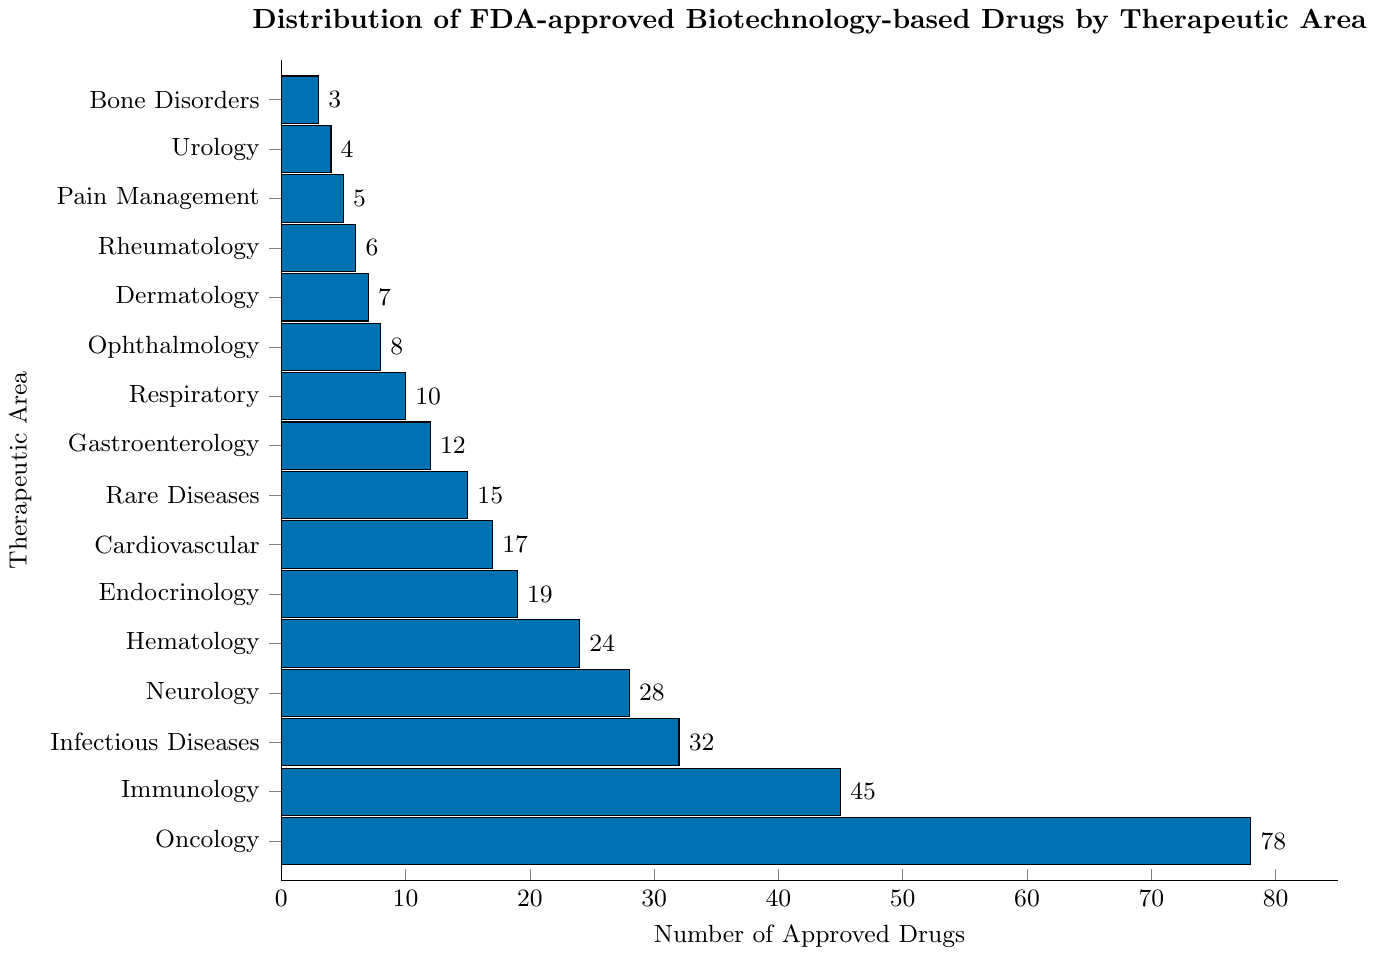what is the therapeutic area with the highest number of approved drugs? The highest number of approved drugs is represented by the tallest bar in the chart. Here, it is "Oncology" with 78 drugs.
Answer: Oncology Which therapeutic area has the fewest approved drugs? The shortest bar in the chart represents the area with the fewest approved drugs. Here, it is "Bone Disorders" with 3 drugs.
Answer: Bone Disorders How many more approved drugs are there in Immunology compared to Hematology? Immunology has 45 drugs and Hematology has 24 drugs. The difference is 45 - 24 = 21 drugs.
Answer: 21 What is the combined total of approved drugs in Neurology and Infectious Diseases? Neurology has 28 drugs and Infectious Diseases have 32 drugs. The combined total is 28 + 32 = 60 drugs.
Answer: 60 Which therapeutic areas have more than 30 approved drugs? From the chart, the therapeutic areas with more than 30 approved drugs are Oncology (78), Immunology (45), Infectious Diseases (32), and Neurology (28 is not more than 30).
Answer: Oncology, Immunology, Infectious Diseases What is the average number of approved drugs across all therapeutic areas? Sum all the provided values: 78 + 45 + 32 + 28 + 24 + 19 + 17 + 15 + 12 + 10 + 8 + 7 + 6 + 5 + 4 + 3 = 313. There are 16 therapeutic areas. The average is 313 / 16 = 19.56 drugs.
Answer: 19.56 How does the number of approved drugs for Cardiovascular compare with Hematology and Rare Diseases combined? Hematology has 24 drugs, and Rare Diseases have 15 drugs, combined total is 24 + 15 = 39 drugs. Cardiovascular has 17 drugs, which is fewer than 39.
Answer: Cardiovascular has fewer Which therapeutic areas have 10 or fewer approved drugs? From the chart, the therapeutic areas with 10 or fewer approved drugs are Respiratory (10), Ophthalmology (8), Dermatology (7), Rheumatology (6), Pain Management (5), Urology (4), and Bone Disorders (3).
Answer: Respiratory, Ophthalmology, Dermatology, Rheumatology, Pain Management, Urology, Bone Disorders How much taller is the Oncology bar compared to the Dermatology bar? Oncology has 78 drugs, and Dermatology has 7 drugs. The difference is 78 - 7 = 71. Hence, the bar for Oncology is 71 units taller than Dermatology.
Answer: 71 